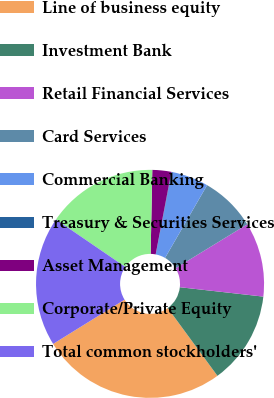<chart> <loc_0><loc_0><loc_500><loc_500><pie_chart><fcel>Line of business equity<fcel>Investment Bank<fcel>Retail Financial Services<fcel>Card Services<fcel>Commercial Banking<fcel>Treasury & Securities Services<fcel>Asset Management<fcel>Corporate/Private Equity<fcel>Total common stockholders'<nl><fcel>26.24%<fcel>13.15%<fcel>10.53%<fcel>7.91%<fcel>5.29%<fcel>0.06%<fcel>2.68%<fcel>15.76%<fcel>18.38%<nl></chart> 